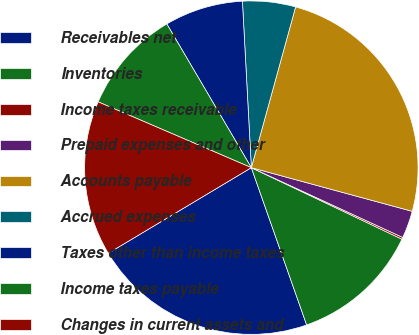Convert chart. <chart><loc_0><loc_0><loc_500><loc_500><pie_chart><fcel>Receivables net<fcel>Inventories<fcel>Income taxes receivable<fcel>Prepaid expenses and other<fcel>Accounts payable<fcel>Accrued expenses<fcel>Taxes other than income taxes<fcel>Income taxes payable<fcel>Changes in current assets and<nl><fcel>21.8%<fcel>12.56%<fcel>0.18%<fcel>2.66%<fcel>24.94%<fcel>5.13%<fcel>7.61%<fcel>10.08%<fcel>15.04%<nl></chart> 